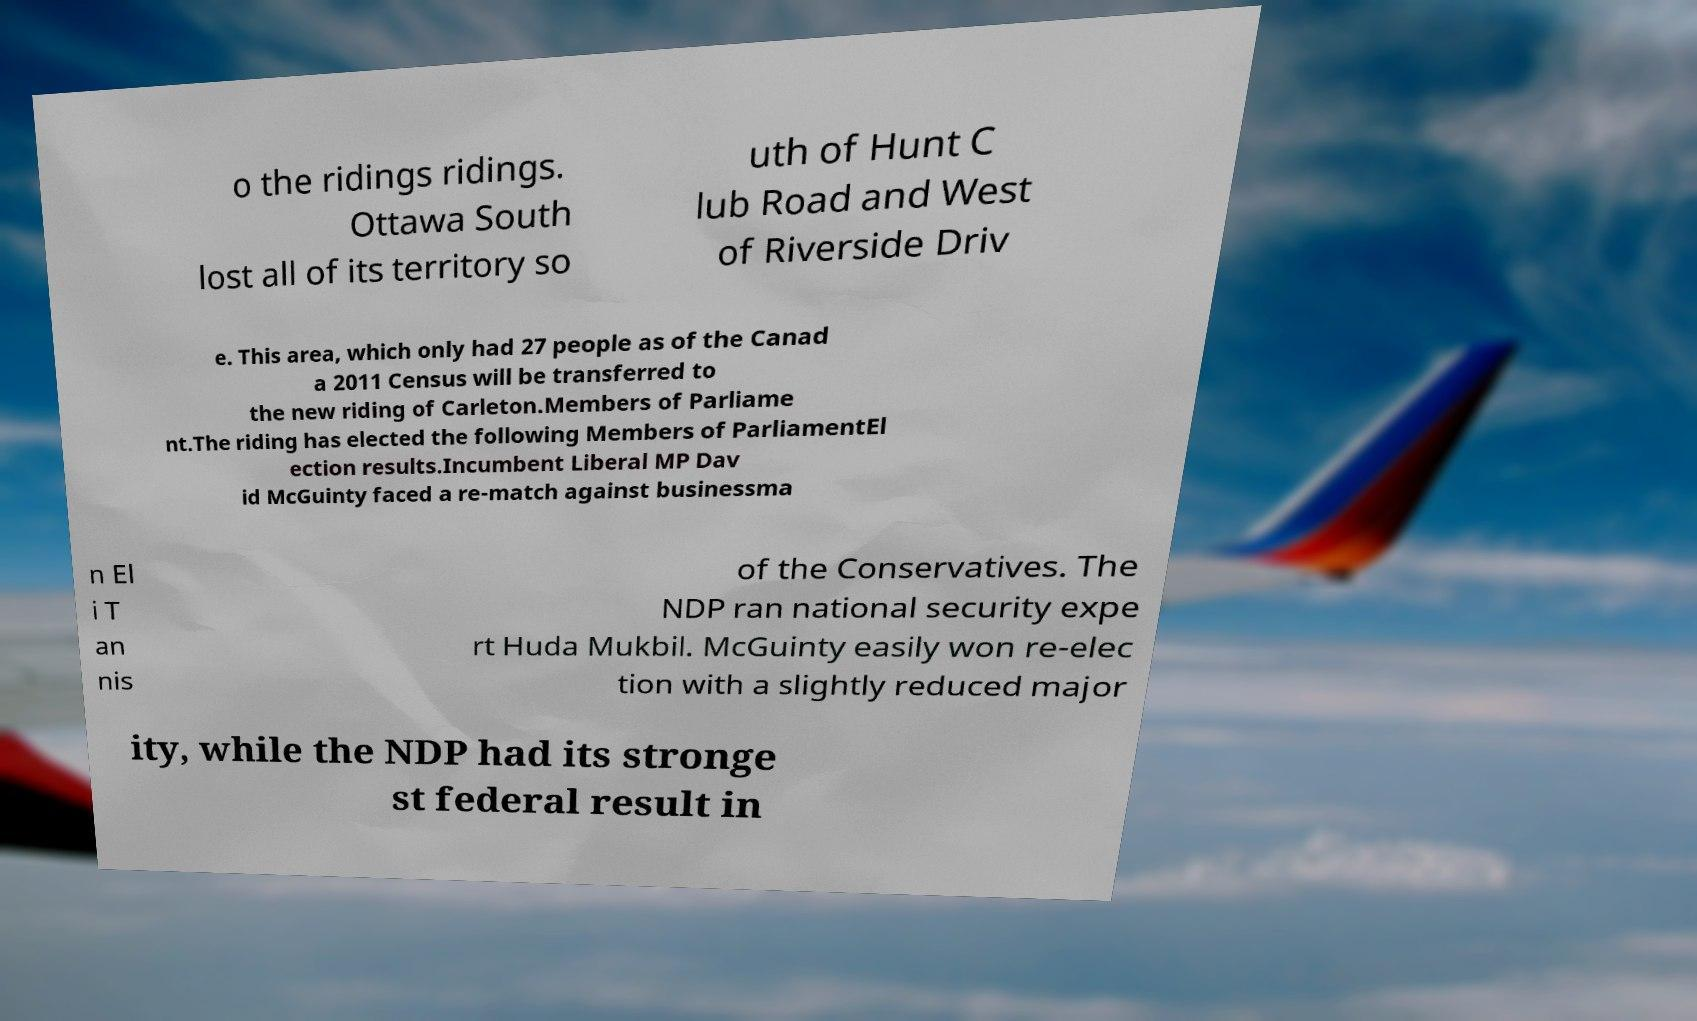There's text embedded in this image that I need extracted. Can you transcribe it verbatim? o the ridings ridings. Ottawa South lost all of its territory so uth of Hunt C lub Road and West of Riverside Driv e. This area, which only had 27 people as of the Canad a 2011 Census will be transferred to the new riding of Carleton.Members of Parliame nt.The riding has elected the following Members of ParliamentEl ection results.Incumbent Liberal MP Dav id McGuinty faced a re-match against businessma n El i T an nis of the Conservatives. The NDP ran national security expe rt Huda Mukbil. McGuinty easily won re-elec tion with a slightly reduced major ity, while the NDP had its stronge st federal result in 